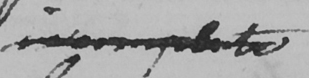What does this handwritten line say? incomplete 